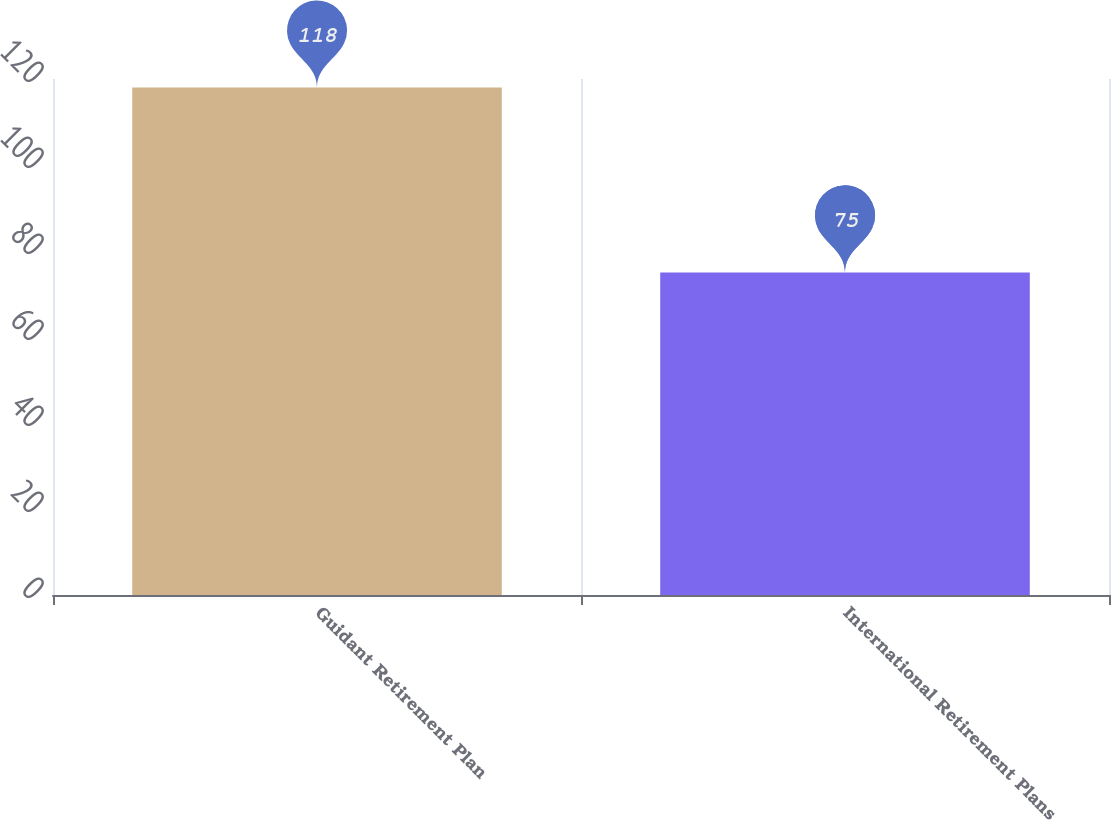<chart> <loc_0><loc_0><loc_500><loc_500><bar_chart><fcel>Guidant Retirement Plan<fcel>International Retirement Plans<nl><fcel>118<fcel>75<nl></chart> 